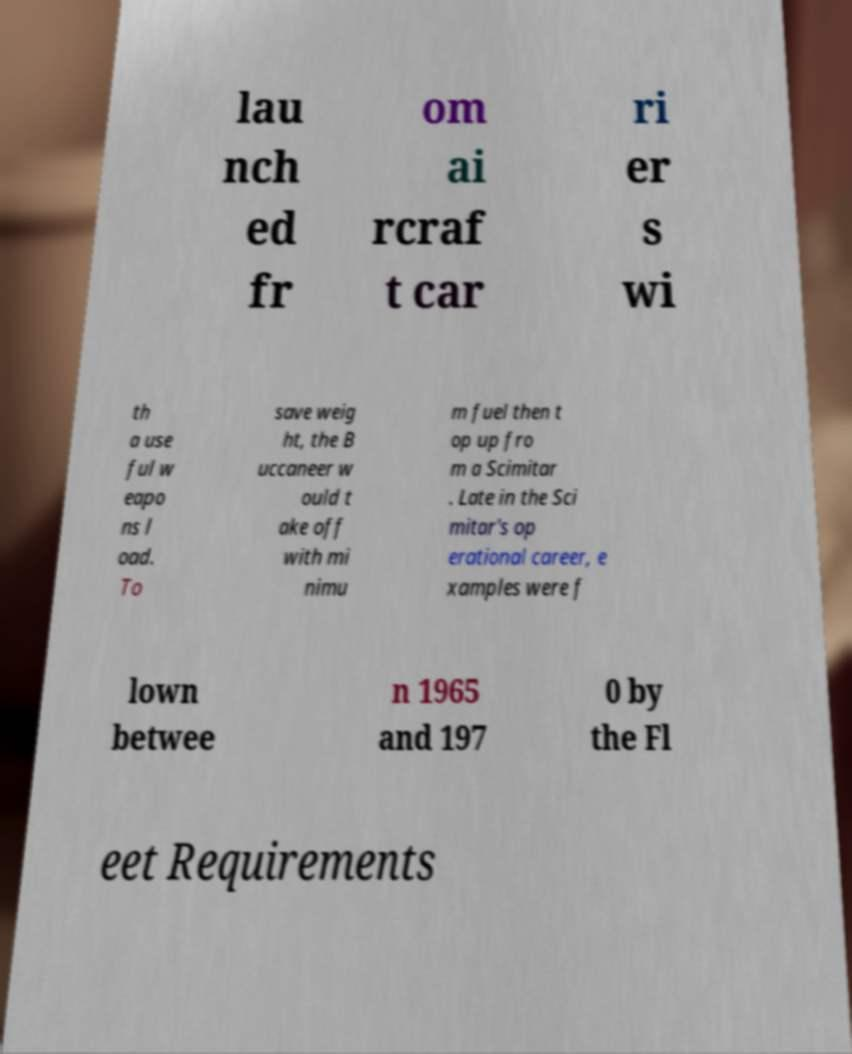I need the written content from this picture converted into text. Can you do that? lau nch ed fr om ai rcraf t car ri er s wi th a use ful w eapo ns l oad. To save weig ht, the B uccaneer w ould t ake off with mi nimu m fuel then t op up fro m a Scimitar . Late in the Sci mitar's op erational career, e xamples were f lown betwee n 1965 and 197 0 by the Fl eet Requirements 